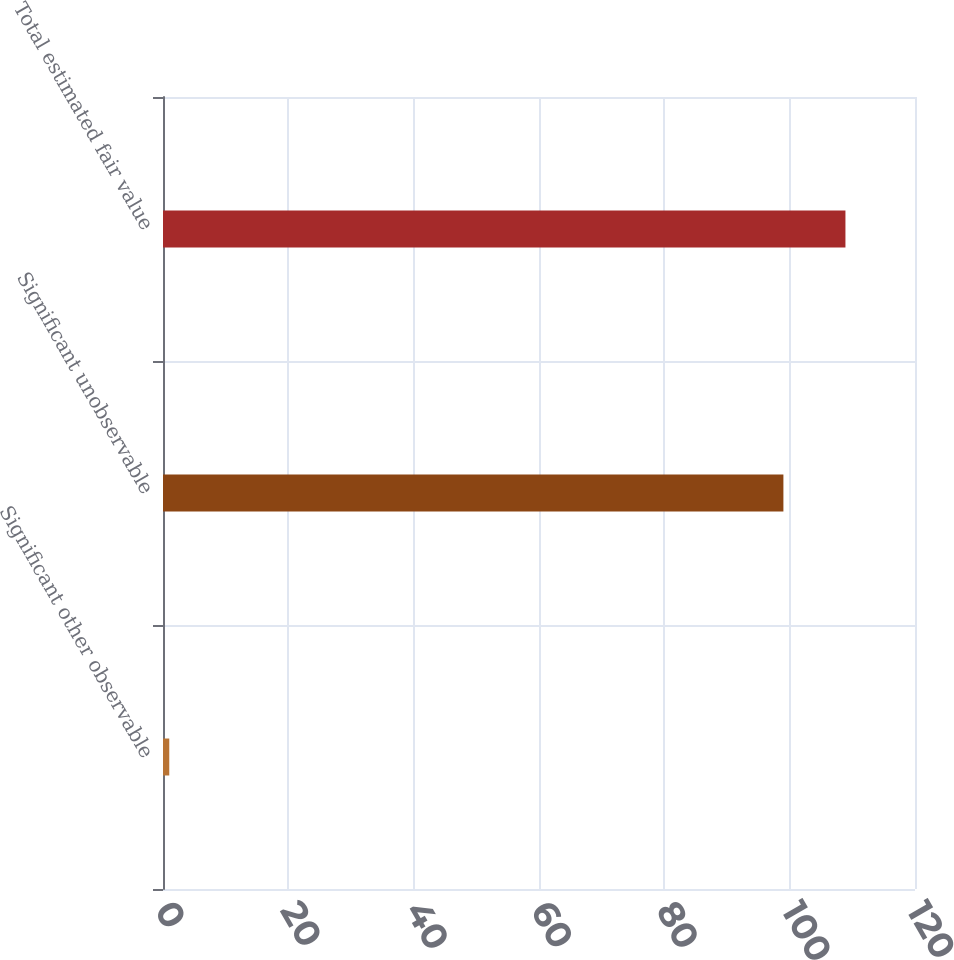Convert chart. <chart><loc_0><loc_0><loc_500><loc_500><bar_chart><fcel>Significant other observable<fcel>Significant unobservable<fcel>Total estimated fair value<nl><fcel>1<fcel>99<fcel>108.9<nl></chart> 